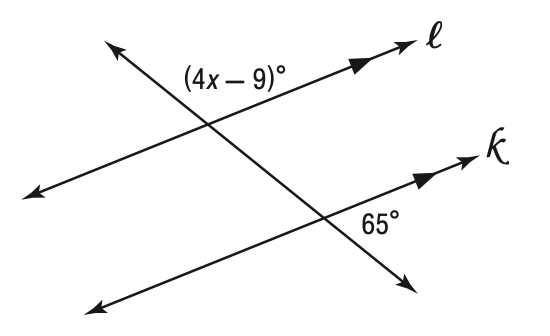Answer the mathemtical geometry problem and directly provide the correct option letter.
Question: Solve for x in the figure below.
Choices: A: 31 B: 59 C: 65 D: 115 A 